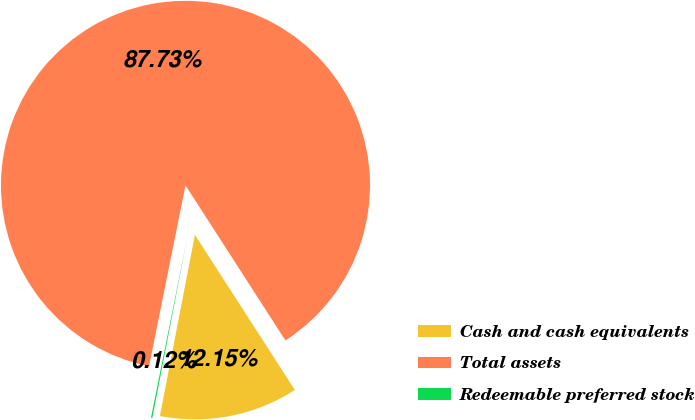<chart> <loc_0><loc_0><loc_500><loc_500><pie_chart><fcel>Cash and cash equivalents<fcel>Total assets<fcel>Redeemable preferred stock<nl><fcel>12.15%<fcel>87.73%<fcel>0.12%<nl></chart> 